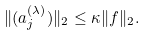Convert formula to latex. <formula><loc_0><loc_0><loc_500><loc_500>\| ( a _ { j } ^ { ( \lambda ) } ) \| _ { 2 } \leq \kappa \| f \| _ { 2 } .</formula> 